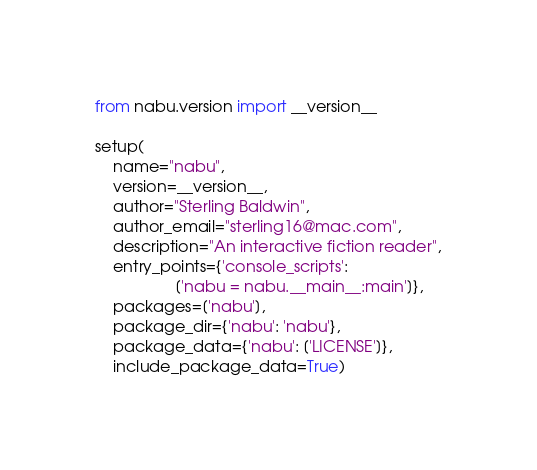Convert code to text. <code><loc_0><loc_0><loc_500><loc_500><_Python_>from nabu.version import __version__

setup(
    name="nabu",
    version=__version__,
    author="Sterling Baldwin",
    author_email="sterling16@mac.com",
    description="An interactive fiction reader",
    entry_points={'console_scripts':
                  ['nabu = nabu.__main__:main']},
    packages=['nabu'],
    package_dir={'nabu': 'nabu'},
    package_data={'nabu': ['LICENSE']},
    include_package_data=True)</code> 